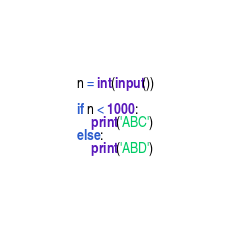<code> <loc_0><loc_0><loc_500><loc_500><_Python_>n = int(input())

if n < 1000:
    print('ABC')
else:
    print('ABD')</code> 